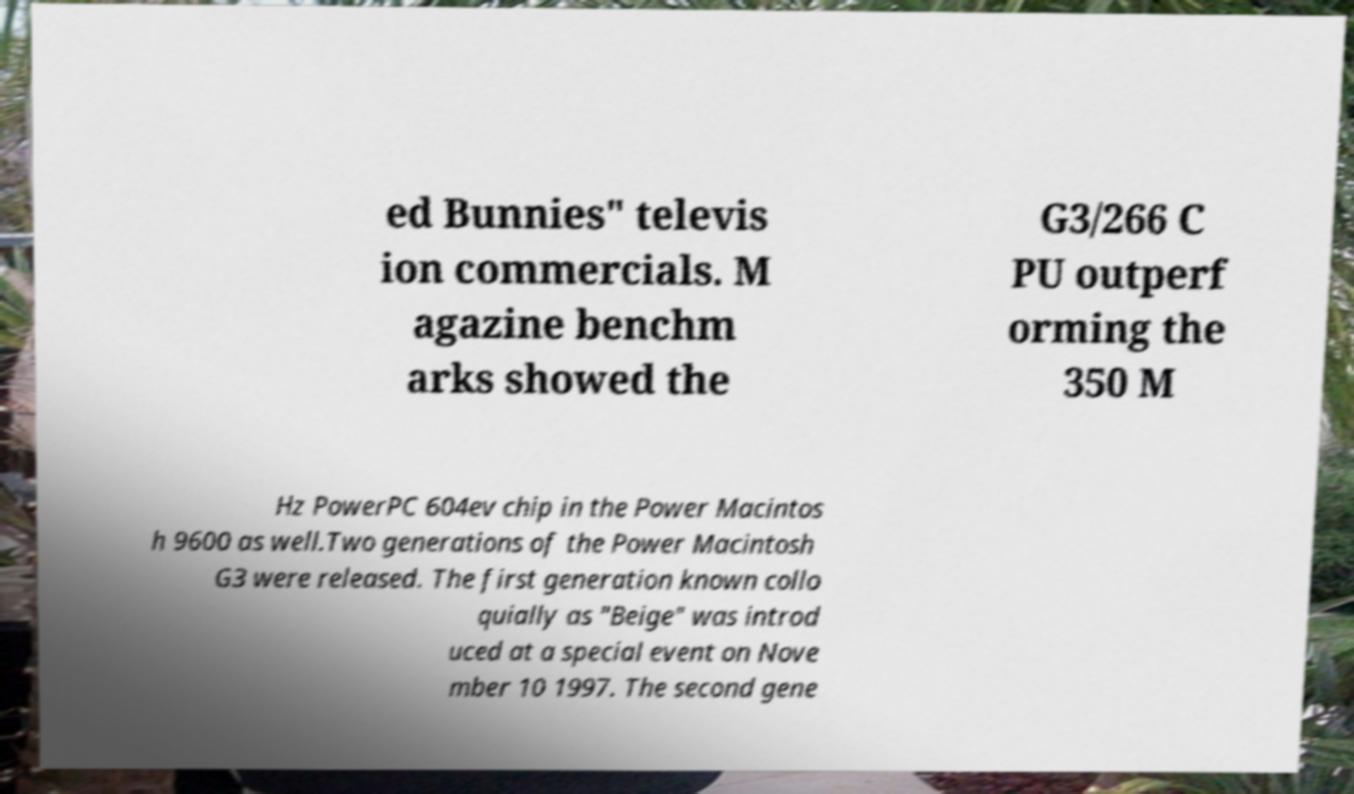Can you read and provide the text displayed in the image?This photo seems to have some interesting text. Can you extract and type it out for me? ed Bunnies" televis ion commercials. M agazine benchm arks showed the G3/266 C PU outperf orming the 350 M Hz PowerPC 604ev chip in the Power Macintos h 9600 as well.Two generations of the Power Macintosh G3 were released. The first generation known collo quially as "Beige" was introd uced at a special event on Nove mber 10 1997. The second gene 